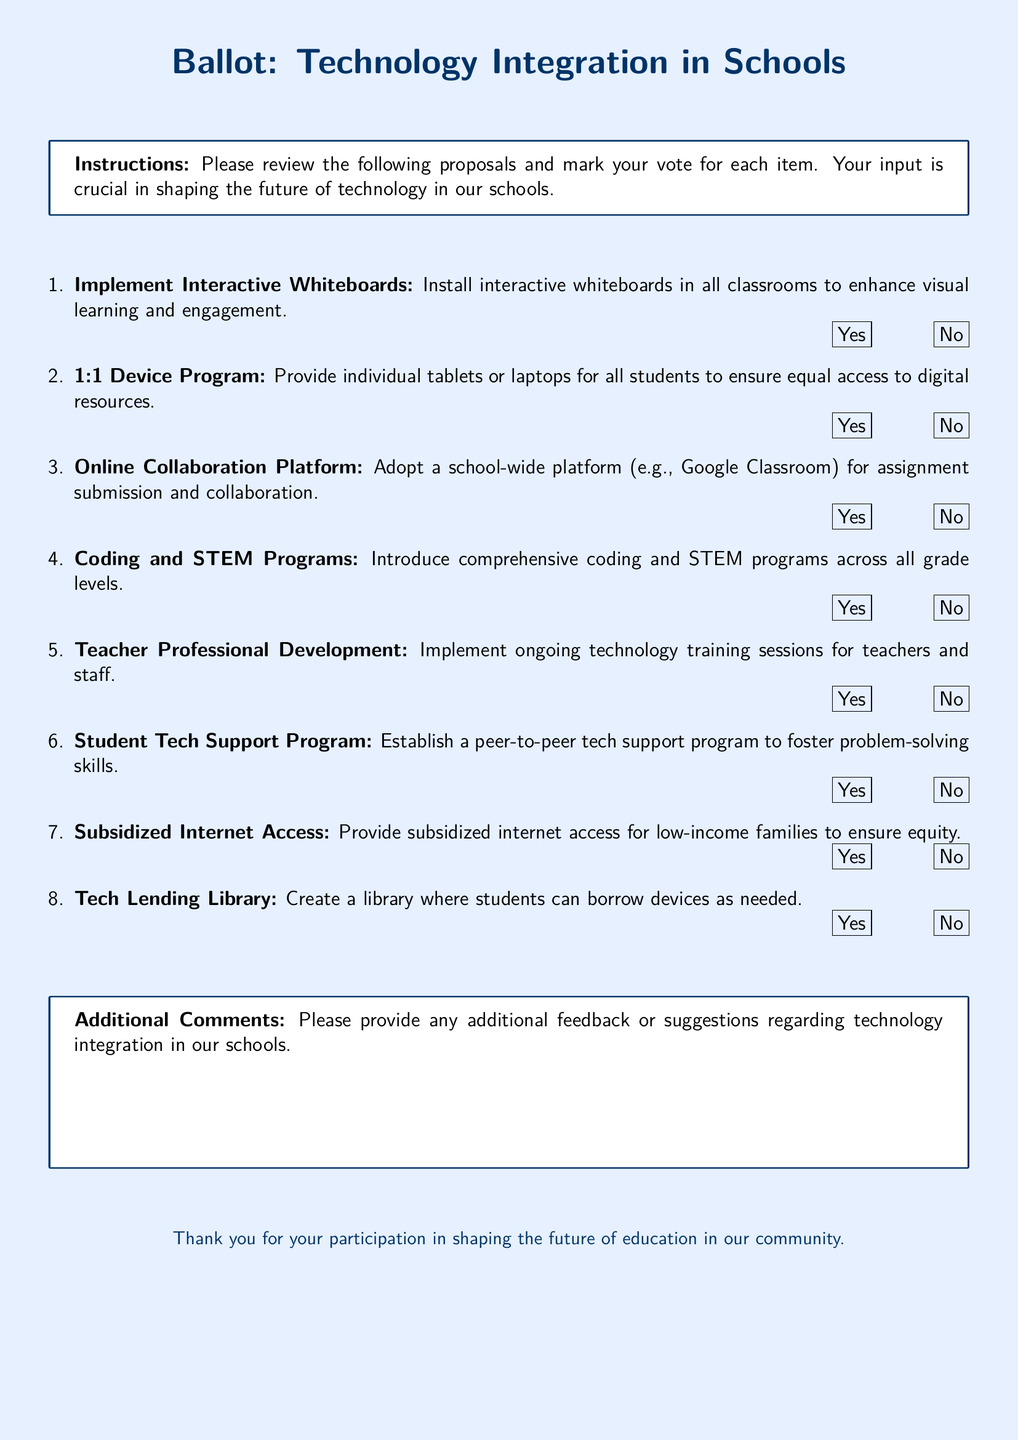What is the title of the document? The title of the document is centered at the top and reads "Ballot: Technology Integration in Schools."
Answer: Ballot: Technology Integration in Schools What is the purpose of this ballot? The purpose is summarized in the instructions, which state that the input is crucial in shaping the future of technology in schools.
Answer: Shaping the future of technology in schools How many technology integration proposals are listed? The document lists a total of eight proposals for technology integration in schools.
Answer: Eight What proposal involves networking and collaboration? The proposal that involves networking and collaboration mentions adopting a school-wide platform for assignment submission and collaboration.
Answer: Online Collaboration Platform What type of training is proposed for teachers? The document proposes ongoing technology training sessions for teachers and staff as part of professional development.
Answer: Ongoing technology training What program aims to foster problem-solving skills among students? The document mentions a peer-to-peer tech support program designed to foster problem-solving skills.
Answer: Student Tech Support Program Is internet access proposed for low-income families? Yes, the document includes a proposal for providing subsidized internet access for low-income families.
Answer: Yes What feedback mechanism is provided at the end of the ballot? The document includes a section for participants to provide additional feedback or suggestions regarding technology integration.
Answer: Additional Comments 